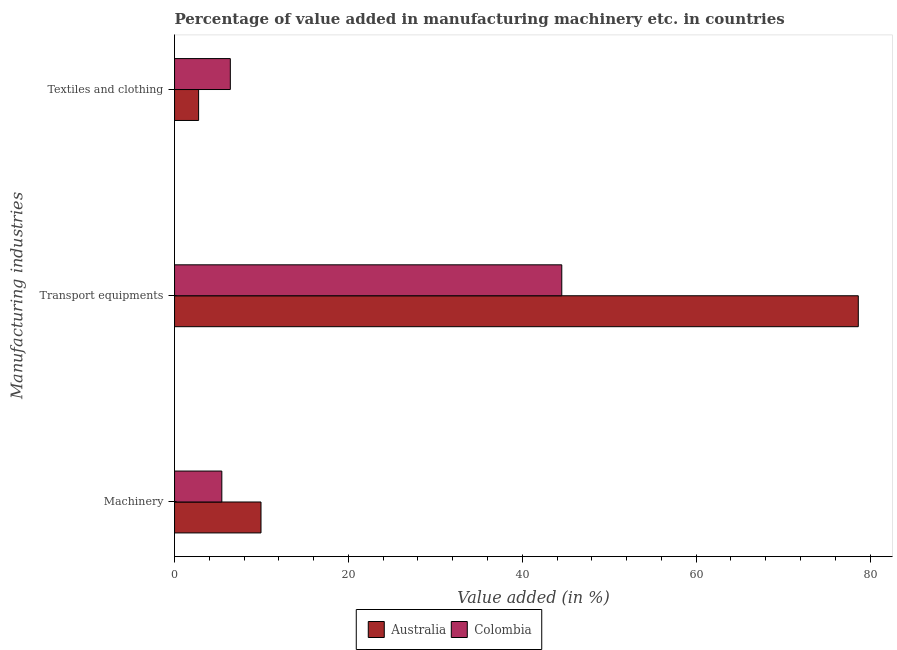How many groups of bars are there?
Make the answer very short. 3. Are the number of bars on each tick of the Y-axis equal?
Offer a very short reply. Yes. How many bars are there on the 2nd tick from the bottom?
Ensure brevity in your answer.  2. What is the label of the 3rd group of bars from the top?
Your answer should be very brief. Machinery. What is the value added in manufacturing transport equipments in Australia?
Keep it short and to the point. 78.65. Across all countries, what is the maximum value added in manufacturing transport equipments?
Provide a succinct answer. 78.65. Across all countries, what is the minimum value added in manufacturing machinery?
Offer a very short reply. 5.44. In which country was the value added in manufacturing textile and clothing maximum?
Keep it short and to the point. Colombia. In which country was the value added in manufacturing machinery minimum?
Keep it short and to the point. Colombia. What is the total value added in manufacturing machinery in the graph?
Give a very brief answer. 15.38. What is the difference between the value added in manufacturing machinery in Australia and that in Colombia?
Keep it short and to the point. 4.5. What is the difference between the value added in manufacturing textile and clothing in Australia and the value added in manufacturing machinery in Colombia?
Your response must be concise. -2.67. What is the average value added in manufacturing transport equipments per country?
Keep it short and to the point. 61.59. What is the difference between the value added in manufacturing transport equipments and value added in manufacturing machinery in Colombia?
Provide a short and direct response. 39.1. What is the ratio of the value added in manufacturing transport equipments in Colombia to that in Australia?
Offer a very short reply. 0.57. Is the value added in manufacturing textile and clothing in Colombia less than that in Australia?
Ensure brevity in your answer.  No. Is the difference between the value added in manufacturing machinery in Colombia and Australia greater than the difference between the value added in manufacturing transport equipments in Colombia and Australia?
Your response must be concise. Yes. What is the difference between the highest and the second highest value added in manufacturing textile and clothing?
Offer a terse response. 3.65. What is the difference between the highest and the lowest value added in manufacturing textile and clothing?
Offer a very short reply. 3.65. In how many countries, is the value added in manufacturing machinery greater than the average value added in manufacturing machinery taken over all countries?
Keep it short and to the point. 1. Is the sum of the value added in manufacturing machinery in Australia and Colombia greater than the maximum value added in manufacturing textile and clothing across all countries?
Offer a very short reply. Yes. What does the 2nd bar from the top in Textiles and clothing represents?
Offer a very short reply. Australia. What does the 2nd bar from the bottom in Machinery represents?
Give a very brief answer. Colombia. Is it the case that in every country, the sum of the value added in manufacturing machinery and value added in manufacturing transport equipments is greater than the value added in manufacturing textile and clothing?
Keep it short and to the point. Yes. Are all the bars in the graph horizontal?
Keep it short and to the point. Yes. Does the graph contain grids?
Offer a terse response. No. How many legend labels are there?
Your answer should be very brief. 2. How are the legend labels stacked?
Your answer should be compact. Horizontal. What is the title of the graph?
Offer a very short reply. Percentage of value added in manufacturing machinery etc. in countries. Does "Singapore" appear as one of the legend labels in the graph?
Provide a short and direct response. No. What is the label or title of the X-axis?
Provide a short and direct response. Value added (in %). What is the label or title of the Y-axis?
Provide a succinct answer. Manufacturing industries. What is the Value added (in %) in Australia in Machinery?
Ensure brevity in your answer.  9.94. What is the Value added (in %) of Colombia in Machinery?
Your answer should be compact. 5.44. What is the Value added (in %) in Australia in Transport equipments?
Provide a short and direct response. 78.65. What is the Value added (in %) in Colombia in Transport equipments?
Keep it short and to the point. 44.54. What is the Value added (in %) of Australia in Textiles and clothing?
Make the answer very short. 2.77. What is the Value added (in %) in Colombia in Textiles and clothing?
Ensure brevity in your answer.  6.42. Across all Manufacturing industries, what is the maximum Value added (in %) in Australia?
Make the answer very short. 78.65. Across all Manufacturing industries, what is the maximum Value added (in %) in Colombia?
Give a very brief answer. 44.54. Across all Manufacturing industries, what is the minimum Value added (in %) of Australia?
Keep it short and to the point. 2.77. Across all Manufacturing industries, what is the minimum Value added (in %) in Colombia?
Make the answer very short. 5.44. What is the total Value added (in %) of Australia in the graph?
Keep it short and to the point. 91.36. What is the total Value added (in %) in Colombia in the graph?
Ensure brevity in your answer.  56.39. What is the difference between the Value added (in %) in Australia in Machinery and that in Transport equipments?
Offer a terse response. -68.7. What is the difference between the Value added (in %) in Colombia in Machinery and that in Transport equipments?
Offer a very short reply. -39.1. What is the difference between the Value added (in %) of Australia in Machinery and that in Textiles and clothing?
Keep it short and to the point. 7.18. What is the difference between the Value added (in %) in Colombia in Machinery and that in Textiles and clothing?
Your answer should be compact. -0.98. What is the difference between the Value added (in %) of Australia in Transport equipments and that in Textiles and clothing?
Your answer should be very brief. 75.88. What is the difference between the Value added (in %) of Colombia in Transport equipments and that in Textiles and clothing?
Your response must be concise. 38.12. What is the difference between the Value added (in %) of Australia in Machinery and the Value added (in %) of Colombia in Transport equipments?
Your answer should be very brief. -34.6. What is the difference between the Value added (in %) in Australia in Machinery and the Value added (in %) in Colombia in Textiles and clothing?
Offer a terse response. 3.53. What is the difference between the Value added (in %) of Australia in Transport equipments and the Value added (in %) of Colombia in Textiles and clothing?
Offer a terse response. 72.23. What is the average Value added (in %) of Australia per Manufacturing industries?
Provide a short and direct response. 30.45. What is the average Value added (in %) in Colombia per Manufacturing industries?
Provide a succinct answer. 18.8. What is the difference between the Value added (in %) of Australia and Value added (in %) of Colombia in Machinery?
Your answer should be compact. 4.5. What is the difference between the Value added (in %) in Australia and Value added (in %) in Colombia in Transport equipments?
Offer a terse response. 34.11. What is the difference between the Value added (in %) in Australia and Value added (in %) in Colombia in Textiles and clothing?
Ensure brevity in your answer.  -3.65. What is the ratio of the Value added (in %) in Australia in Machinery to that in Transport equipments?
Your answer should be compact. 0.13. What is the ratio of the Value added (in %) in Colombia in Machinery to that in Transport equipments?
Your response must be concise. 0.12. What is the ratio of the Value added (in %) of Australia in Machinery to that in Textiles and clothing?
Provide a succinct answer. 3.59. What is the ratio of the Value added (in %) in Colombia in Machinery to that in Textiles and clothing?
Your response must be concise. 0.85. What is the ratio of the Value added (in %) in Australia in Transport equipments to that in Textiles and clothing?
Give a very brief answer. 28.42. What is the ratio of the Value added (in %) in Colombia in Transport equipments to that in Textiles and clothing?
Your response must be concise. 6.94. What is the difference between the highest and the second highest Value added (in %) of Australia?
Your answer should be compact. 68.7. What is the difference between the highest and the second highest Value added (in %) of Colombia?
Your response must be concise. 38.12. What is the difference between the highest and the lowest Value added (in %) of Australia?
Provide a short and direct response. 75.88. What is the difference between the highest and the lowest Value added (in %) in Colombia?
Your answer should be compact. 39.1. 